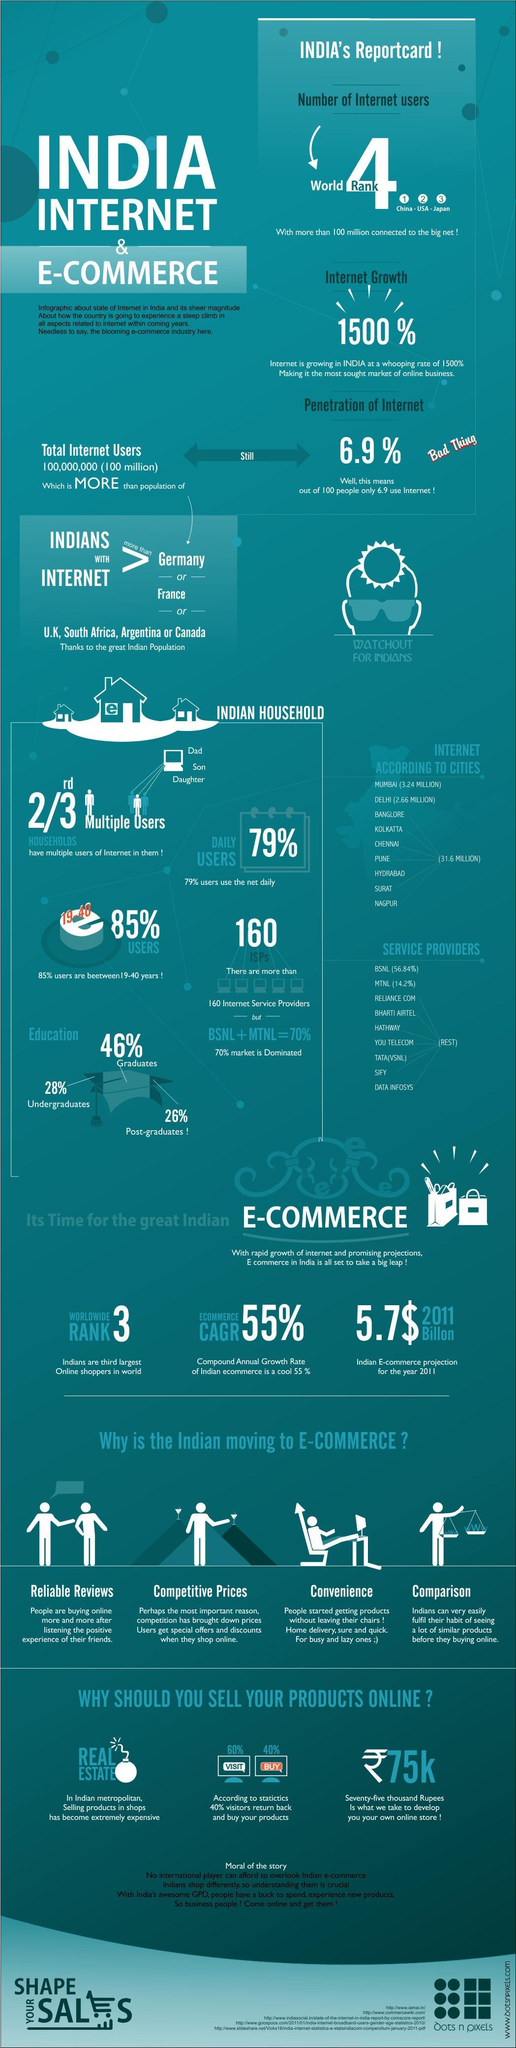Which country holds the second rank in internet usage, USA, India, or China?
Answer the question with a short phrase. USA What percentage of users do not use the internet everyday? 21% Which group of internet user based on education use internet the most, undergraduates, post-graduates, or graduates? graduates How many countries have lower internet users than India? 6 